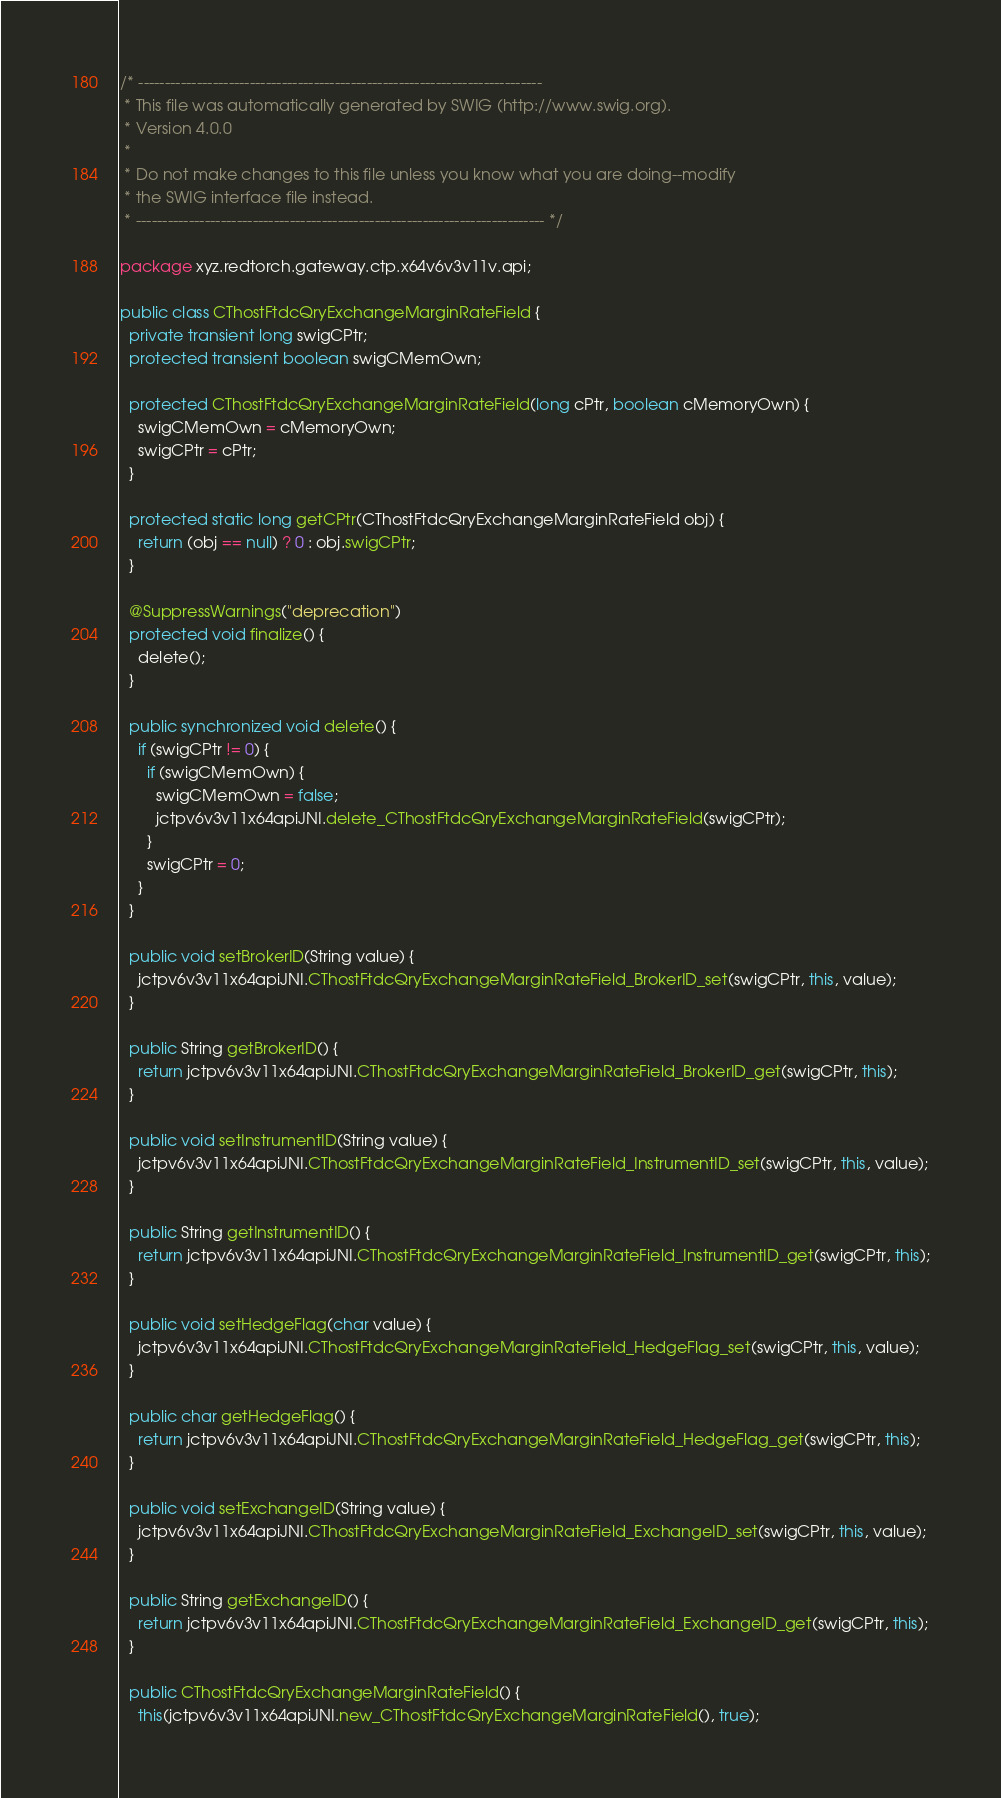<code> <loc_0><loc_0><loc_500><loc_500><_Java_>/* ----------------------------------------------------------------------------
 * This file was automatically generated by SWIG (http://www.swig.org).
 * Version 4.0.0
 *
 * Do not make changes to this file unless you know what you are doing--modify
 * the SWIG interface file instead.
 * ----------------------------------------------------------------------------- */

package xyz.redtorch.gateway.ctp.x64v6v3v11v.api;

public class CThostFtdcQryExchangeMarginRateField {
  private transient long swigCPtr;
  protected transient boolean swigCMemOwn;

  protected CThostFtdcQryExchangeMarginRateField(long cPtr, boolean cMemoryOwn) {
    swigCMemOwn = cMemoryOwn;
    swigCPtr = cPtr;
  }

  protected static long getCPtr(CThostFtdcQryExchangeMarginRateField obj) {
    return (obj == null) ? 0 : obj.swigCPtr;
  }

  @SuppressWarnings("deprecation")
  protected void finalize() {
    delete();
  }

  public synchronized void delete() {
    if (swigCPtr != 0) {
      if (swigCMemOwn) {
        swigCMemOwn = false;
        jctpv6v3v11x64apiJNI.delete_CThostFtdcQryExchangeMarginRateField(swigCPtr);
      }
      swigCPtr = 0;
    }
  }

  public void setBrokerID(String value) {
    jctpv6v3v11x64apiJNI.CThostFtdcQryExchangeMarginRateField_BrokerID_set(swigCPtr, this, value);
  }

  public String getBrokerID() {
    return jctpv6v3v11x64apiJNI.CThostFtdcQryExchangeMarginRateField_BrokerID_get(swigCPtr, this);
  }

  public void setInstrumentID(String value) {
    jctpv6v3v11x64apiJNI.CThostFtdcQryExchangeMarginRateField_InstrumentID_set(swigCPtr, this, value);
  }

  public String getInstrumentID() {
    return jctpv6v3v11x64apiJNI.CThostFtdcQryExchangeMarginRateField_InstrumentID_get(swigCPtr, this);
  }

  public void setHedgeFlag(char value) {
    jctpv6v3v11x64apiJNI.CThostFtdcQryExchangeMarginRateField_HedgeFlag_set(swigCPtr, this, value);
  }

  public char getHedgeFlag() {
    return jctpv6v3v11x64apiJNI.CThostFtdcQryExchangeMarginRateField_HedgeFlag_get(swigCPtr, this);
  }

  public void setExchangeID(String value) {
    jctpv6v3v11x64apiJNI.CThostFtdcQryExchangeMarginRateField_ExchangeID_set(swigCPtr, this, value);
  }

  public String getExchangeID() {
    return jctpv6v3v11x64apiJNI.CThostFtdcQryExchangeMarginRateField_ExchangeID_get(swigCPtr, this);
  }

  public CThostFtdcQryExchangeMarginRateField() {
    this(jctpv6v3v11x64apiJNI.new_CThostFtdcQryExchangeMarginRateField(), true);</code> 